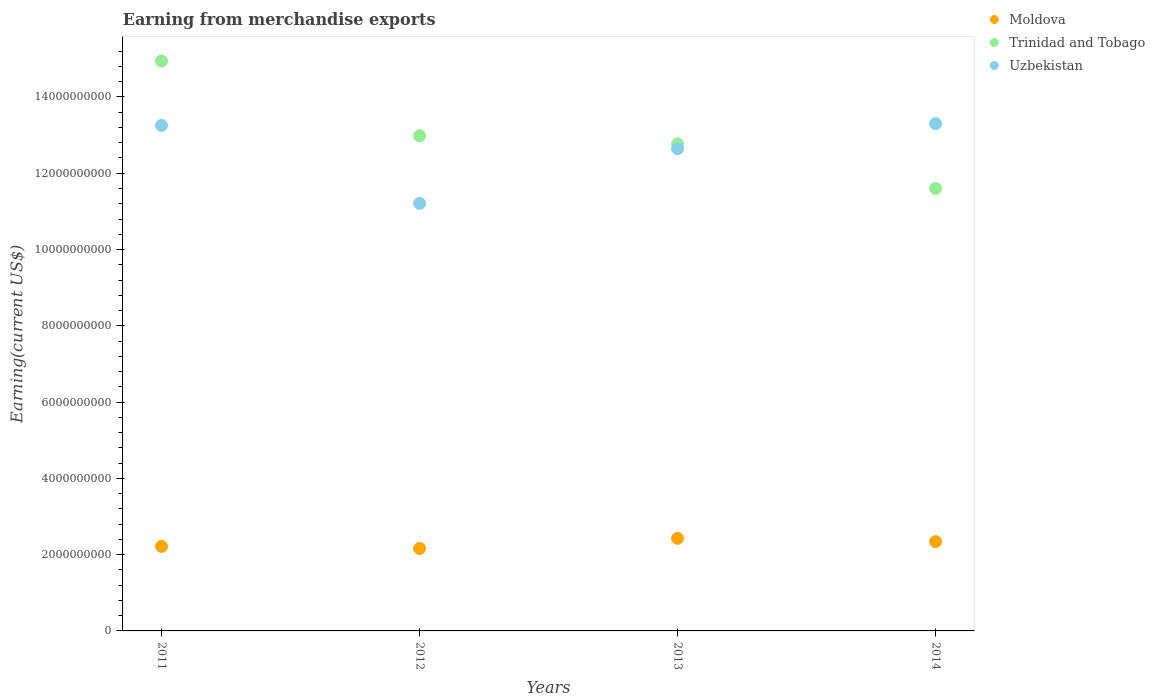What is the amount earned from merchandise exports in Uzbekistan in 2012?
Offer a very short reply. 1.12e+1. Across all years, what is the maximum amount earned from merchandise exports in Uzbekistan?
Provide a short and direct response. 1.33e+1. Across all years, what is the minimum amount earned from merchandise exports in Uzbekistan?
Offer a terse response. 1.12e+1. In which year was the amount earned from merchandise exports in Trinidad and Tobago minimum?
Ensure brevity in your answer.  2014. What is the total amount earned from merchandise exports in Trinidad and Tobago in the graph?
Your answer should be very brief. 5.23e+1. What is the difference between the amount earned from merchandise exports in Uzbekistan in 2012 and that in 2014?
Make the answer very short. -2.09e+09. What is the difference between the amount earned from merchandise exports in Uzbekistan in 2011 and the amount earned from merchandise exports in Trinidad and Tobago in 2014?
Offer a terse response. 1.65e+09. What is the average amount earned from merchandise exports in Trinidad and Tobago per year?
Keep it short and to the point. 1.31e+1. In the year 2011, what is the difference between the amount earned from merchandise exports in Trinidad and Tobago and amount earned from merchandise exports in Moldova?
Your answer should be compact. 1.27e+1. What is the ratio of the amount earned from merchandise exports in Trinidad and Tobago in 2011 to that in 2012?
Offer a very short reply. 1.15. What is the difference between the highest and the second highest amount earned from merchandise exports in Moldova?
Your answer should be very brief. 8.88e+07. What is the difference between the highest and the lowest amount earned from merchandise exports in Moldova?
Ensure brevity in your answer.  2.66e+08. Does the amount earned from merchandise exports in Trinidad and Tobago monotonically increase over the years?
Ensure brevity in your answer.  No. Is the amount earned from merchandise exports in Uzbekistan strictly greater than the amount earned from merchandise exports in Moldova over the years?
Your response must be concise. Yes. Is the amount earned from merchandise exports in Trinidad and Tobago strictly less than the amount earned from merchandise exports in Uzbekistan over the years?
Make the answer very short. No. How many dotlines are there?
Your response must be concise. 3. What is the difference between two consecutive major ticks on the Y-axis?
Offer a terse response. 2.00e+09. Are the values on the major ticks of Y-axis written in scientific E-notation?
Ensure brevity in your answer.  No. Does the graph contain grids?
Offer a terse response. No. How many legend labels are there?
Your answer should be compact. 3. What is the title of the graph?
Your answer should be very brief. Earning from merchandise exports. Does "Lao PDR" appear as one of the legend labels in the graph?
Offer a terse response. No. What is the label or title of the X-axis?
Your answer should be compact. Years. What is the label or title of the Y-axis?
Make the answer very short. Earning(current US$). What is the Earning(current US$) of Moldova in 2011?
Offer a terse response. 2.22e+09. What is the Earning(current US$) of Trinidad and Tobago in 2011?
Your response must be concise. 1.49e+1. What is the Earning(current US$) in Uzbekistan in 2011?
Keep it short and to the point. 1.33e+1. What is the Earning(current US$) in Moldova in 2012?
Your answer should be very brief. 2.16e+09. What is the Earning(current US$) of Trinidad and Tobago in 2012?
Make the answer very short. 1.30e+1. What is the Earning(current US$) in Uzbekistan in 2012?
Offer a terse response. 1.12e+1. What is the Earning(current US$) of Moldova in 2013?
Offer a very short reply. 2.43e+09. What is the Earning(current US$) of Trinidad and Tobago in 2013?
Make the answer very short. 1.28e+1. What is the Earning(current US$) of Uzbekistan in 2013?
Ensure brevity in your answer.  1.26e+1. What is the Earning(current US$) in Moldova in 2014?
Keep it short and to the point. 2.34e+09. What is the Earning(current US$) of Trinidad and Tobago in 2014?
Ensure brevity in your answer.  1.16e+1. What is the Earning(current US$) in Uzbekistan in 2014?
Your answer should be compact. 1.33e+1. Across all years, what is the maximum Earning(current US$) of Moldova?
Offer a terse response. 2.43e+09. Across all years, what is the maximum Earning(current US$) in Trinidad and Tobago?
Keep it short and to the point. 1.49e+1. Across all years, what is the maximum Earning(current US$) in Uzbekistan?
Offer a terse response. 1.33e+1. Across all years, what is the minimum Earning(current US$) in Moldova?
Make the answer very short. 2.16e+09. Across all years, what is the minimum Earning(current US$) in Trinidad and Tobago?
Offer a very short reply. 1.16e+1. Across all years, what is the minimum Earning(current US$) of Uzbekistan?
Ensure brevity in your answer.  1.12e+1. What is the total Earning(current US$) in Moldova in the graph?
Provide a succinct answer. 9.15e+09. What is the total Earning(current US$) of Trinidad and Tobago in the graph?
Your response must be concise. 5.23e+1. What is the total Earning(current US$) in Uzbekistan in the graph?
Offer a very short reply. 5.04e+1. What is the difference between the Earning(current US$) of Moldova in 2011 and that in 2012?
Your answer should be very brief. 5.49e+07. What is the difference between the Earning(current US$) in Trinidad and Tobago in 2011 and that in 2012?
Keep it short and to the point. 1.96e+09. What is the difference between the Earning(current US$) of Uzbekistan in 2011 and that in 2012?
Offer a very short reply. 2.04e+09. What is the difference between the Earning(current US$) of Moldova in 2011 and that in 2013?
Your answer should be compact. -2.12e+08. What is the difference between the Earning(current US$) in Trinidad and Tobago in 2011 and that in 2013?
Give a very brief answer. 2.17e+09. What is the difference between the Earning(current US$) of Uzbekistan in 2011 and that in 2013?
Provide a short and direct response. 6.11e+08. What is the difference between the Earning(current US$) in Moldova in 2011 and that in 2014?
Provide a short and direct response. -1.23e+08. What is the difference between the Earning(current US$) in Trinidad and Tobago in 2011 and that in 2014?
Your answer should be very brief. 3.34e+09. What is the difference between the Earning(current US$) in Uzbekistan in 2011 and that in 2014?
Your response must be concise. -4.60e+07. What is the difference between the Earning(current US$) in Moldova in 2012 and that in 2013?
Offer a terse response. -2.66e+08. What is the difference between the Earning(current US$) of Trinidad and Tobago in 2012 and that in 2013?
Provide a succinct answer. 2.14e+08. What is the difference between the Earning(current US$) of Uzbekistan in 2012 and that in 2013?
Provide a succinct answer. -1.43e+09. What is the difference between the Earning(current US$) in Moldova in 2012 and that in 2014?
Ensure brevity in your answer.  -1.78e+08. What is the difference between the Earning(current US$) in Trinidad and Tobago in 2012 and that in 2014?
Give a very brief answer. 1.38e+09. What is the difference between the Earning(current US$) of Uzbekistan in 2012 and that in 2014?
Provide a short and direct response. -2.09e+09. What is the difference between the Earning(current US$) in Moldova in 2013 and that in 2014?
Your answer should be compact. 8.88e+07. What is the difference between the Earning(current US$) of Trinidad and Tobago in 2013 and that in 2014?
Provide a succinct answer. 1.17e+09. What is the difference between the Earning(current US$) of Uzbekistan in 2013 and that in 2014?
Keep it short and to the point. -6.57e+08. What is the difference between the Earning(current US$) of Moldova in 2011 and the Earning(current US$) of Trinidad and Tobago in 2012?
Offer a terse response. -1.08e+1. What is the difference between the Earning(current US$) in Moldova in 2011 and the Earning(current US$) in Uzbekistan in 2012?
Make the answer very short. -8.99e+09. What is the difference between the Earning(current US$) in Trinidad and Tobago in 2011 and the Earning(current US$) in Uzbekistan in 2012?
Provide a short and direct response. 3.73e+09. What is the difference between the Earning(current US$) in Moldova in 2011 and the Earning(current US$) in Trinidad and Tobago in 2013?
Your response must be concise. -1.06e+1. What is the difference between the Earning(current US$) of Moldova in 2011 and the Earning(current US$) of Uzbekistan in 2013?
Your response must be concise. -1.04e+1. What is the difference between the Earning(current US$) in Trinidad and Tobago in 2011 and the Earning(current US$) in Uzbekistan in 2013?
Your answer should be very brief. 2.30e+09. What is the difference between the Earning(current US$) of Moldova in 2011 and the Earning(current US$) of Trinidad and Tobago in 2014?
Your response must be concise. -9.38e+09. What is the difference between the Earning(current US$) in Moldova in 2011 and the Earning(current US$) in Uzbekistan in 2014?
Your answer should be very brief. -1.11e+1. What is the difference between the Earning(current US$) in Trinidad and Tobago in 2011 and the Earning(current US$) in Uzbekistan in 2014?
Ensure brevity in your answer.  1.64e+09. What is the difference between the Earning(current US$) in Moldova in 2012 and the Earning(current US$) in Trinidad and Tobago in 2013?
Offer a terse response. -1.06e+1. What is the difference between the Earning(current US$) of Moldova in 2012 and the Earning(current US$) of Uzbekistan in 2013?
Offer a terse response. -1.05e+1. What is the difference between the Earning(current US$) in Trinidad and Tobago in 2012 and the Earning(current US$) in Uzbekistan in 2013?
Make the answer very short. 3.40e+08. What is the difference between the Earning(current US$) of Moldova in 2012 and the Earning(current US$) of Trinidad and Tobago in 2014?
Make the answer very short. -9.44e+09. What is the difference between the Earning(current US$) of Moldova in 2012 and the Earning(current US$) of Uzbekistan in 2014?
Your answer should be compact. -1.11e+1. What is the difference between the Earning(current US$) in Trinidad and Tobago in 2012 and the Earning(current US$) in Uzbekistan in 2014?
Offer a very short reply. -3.17e+08. What is the difference between the Earning(current US$) of Moldova in 2013 and the Earning(current US$) of Trinidad and Tobago in 2014?
Your response must be concise. -9.17e+09. What is the difference between the Earning(current US$) in Moldova in 2013 and the Earning(current US$) in Uzbekistan in 2014?
Provide a short and direct response. -1.09e+1. What is the difference between the Earning(current US$) in Trinidad and Tobago in 2013 and the Earning(current US$) in Uzbekistan in 2014?
Offer a terse response. -5.30e+08. What is the average Earning(current US$) of Moldova per year?
Your response must be concise. 2.29e+09. What is the average Earning(current US$) in Trinidad and Tobago per year?
Your answer should be very brief. 1.31e+1. What is the average Earning(current US$) in Uzbekistan per year?
Make the answer very short. 1.26e+1. In the year 2011, what is the difference between the Earning(current US$) in Moldova and Earning(current US$) in Trinidad and Tobago?
Provide a short and direct response. -1.27e+1. In the year 2011, what is the difference between the Earning(current US$) of Moldova and Earning(current US$) of Uzbekistan?
Your answer should be very brief. -1.10e+1. In the year 2011, what is the difference between the Earning(current US$) in Trinidad and Tobago and Earning(current US$) in Uzbekistan?
Provide a succinct answer. 1.69e+09. In the year 2012, what is the difference between the Earning(current US$) in Moldova and Earning(current US$) in Trinidad and Tobago?
Keep it short and to the point. -1.08e+1. In the year 2012, what is the difference between the Earning(current US$) in Moldova and Earning(current US$) in Uzbekistan?
Provide a short and direct response. -9.05e+09. In the year 2012, what is the difference between the Earning(current US$) in Trinidad and Tobago and Earning(current US$) in Uzbekistan?
Your response must be concise. 1.77e+09. In the year 2013, what is the difference between the Earning(current US$) in Moldova and Earning(current US$) in Trinidad and Tobago?
Ensure brevity in your answer.  -1.03e+1. In the year 2013, what is the difference between the Earning(current US$) of Moldova and Earning(current US$) of Uzbekistan?
Ensure brevity in your answer.  -1.02e+1. In the year 2013, what is the difference between the Earning(current US$) in Trinidad and Tobago and Earning(current US$) in Uzbekistan?
Keep it short and to the point. 1.27e+08. In the year 2014, what is the difference between the Earning(current US$) in Moldova and Earning(current US$) in Trinidad and Tobago?
Offer a terse response. -9.26e+09. In the year 2014, what is the difference between the Earning(current US$) in Moldova and Earning(current US$) in Uzbekistan?
Offer a very short reply. -1.10e+1. In the year 2014, what is the difference between the Earning(current US$) of Trinidad and Tobago and Earning(current US$) of Uzbekistan?
Offer a very short reply. -1.70e+09. What is the ratio of the Earning(current US$) of Moldova in 2011 to that in 2012?
Give a very brief answer. 1.03. What is the ratio of the Earning(current US$) of Trinidad and Tobago in 2011 to that in 2012?
Offer a very short reply. 1.15. What is the ratio of the Earning(current US$) in Uzbekistan in 2011 to that in 2012?
Give a very brief answer. 1.18. What is the ratio of the Earning(current US$) of Moldova in 2011 to that in 2013?
Give a very brief answer. 0.91. What is the ratio of the Earning(current US$) in Trinidad and Tobago in 2011 to that in 2013?
Ensure brevity in your answer.  1.17. What is the ratio of the Earning(current US$) of Uzbekistan in 2011 to that in 2013?
Give a very brief answer. 1.05. What is the ratio of the Earning(current US$) of Moldova in 2011 to that in 2014?
Ensure brevity in your answer.  0.95. What is the ratio of the Earning(current US$) in Trinidad and Tobago in 2011 to that in 2014?
Make the answer very short. 1.29. What is the ratio of the Earning(current US$) of Uzbekistan in 2011 to that in 2014?
Your answer should be compact. 1. What is the ratio of the Earning(current US$) of Moldova in 2012 to that in 2013?
Provide a succinct answer. 0.89. What is the ratio of the Earning(current US$) of Trinidad and Tobago in 2012 to that in 2013?
Keep it short and to the point. 1.02. What is the ratio of the Earning(current US$) of Uzbekistan in 2012 to that in 2013?
Keep it short and to the point. 0.89. What is the ratio of the Earning(current US$) of Moldova in 2012 to that in 2014?
Offer a very short reply. 0.92. What is the ratio of the Earning(current US$) in Trinidad and Tobago in 2012 to that in 2014?
Provide a succinct answer. 1.12. What is the ratio of the Earning(current US$) of Uzbekistan in 2012 to that in 2014?
Your answer should be very brief. 0.84. What is the ratio of the Earning(current US$) of Moldova in 2013 to that in 2014?
Keep it short and to the point. 1.04. What is the ratio of the Earning(current US$) in Trinidad and Tobago in 2013 to that in 2014?
Your answer should be compact. 1.1. What is the ratio of the Earning(current US$) in Uzbekistan in 2013 to that in 2014?
Your response must be concise. 0.95. What is the difference between the highest and the second highest Earning(current US$) of Moldova?
Provide a short and direct response. 8.88e+07. What is the difference between the highest and the second highest Earning(current US$) in Trinidad and Tobago?
Provide a short and direct response. 1.96e+09. What is the difference between the highest and the second highest Earning(current US$) of Uzbekistan?
Provide a short and direct response. 4.60e+07. What is the difference between the highest and the lowest Earning(current US$) of Moldova?
Provide a short and direct response. 2.66e+08. What is the difference between the highest and the lowest Earning(current US$) of Trinidad and Tobago?
Your answer should be compact. 3.34e+09. What is the difference between the highest and the lowest Earning(current US$) of Uzbekistan?
Keep it short and to the point. 2.09e+09. 